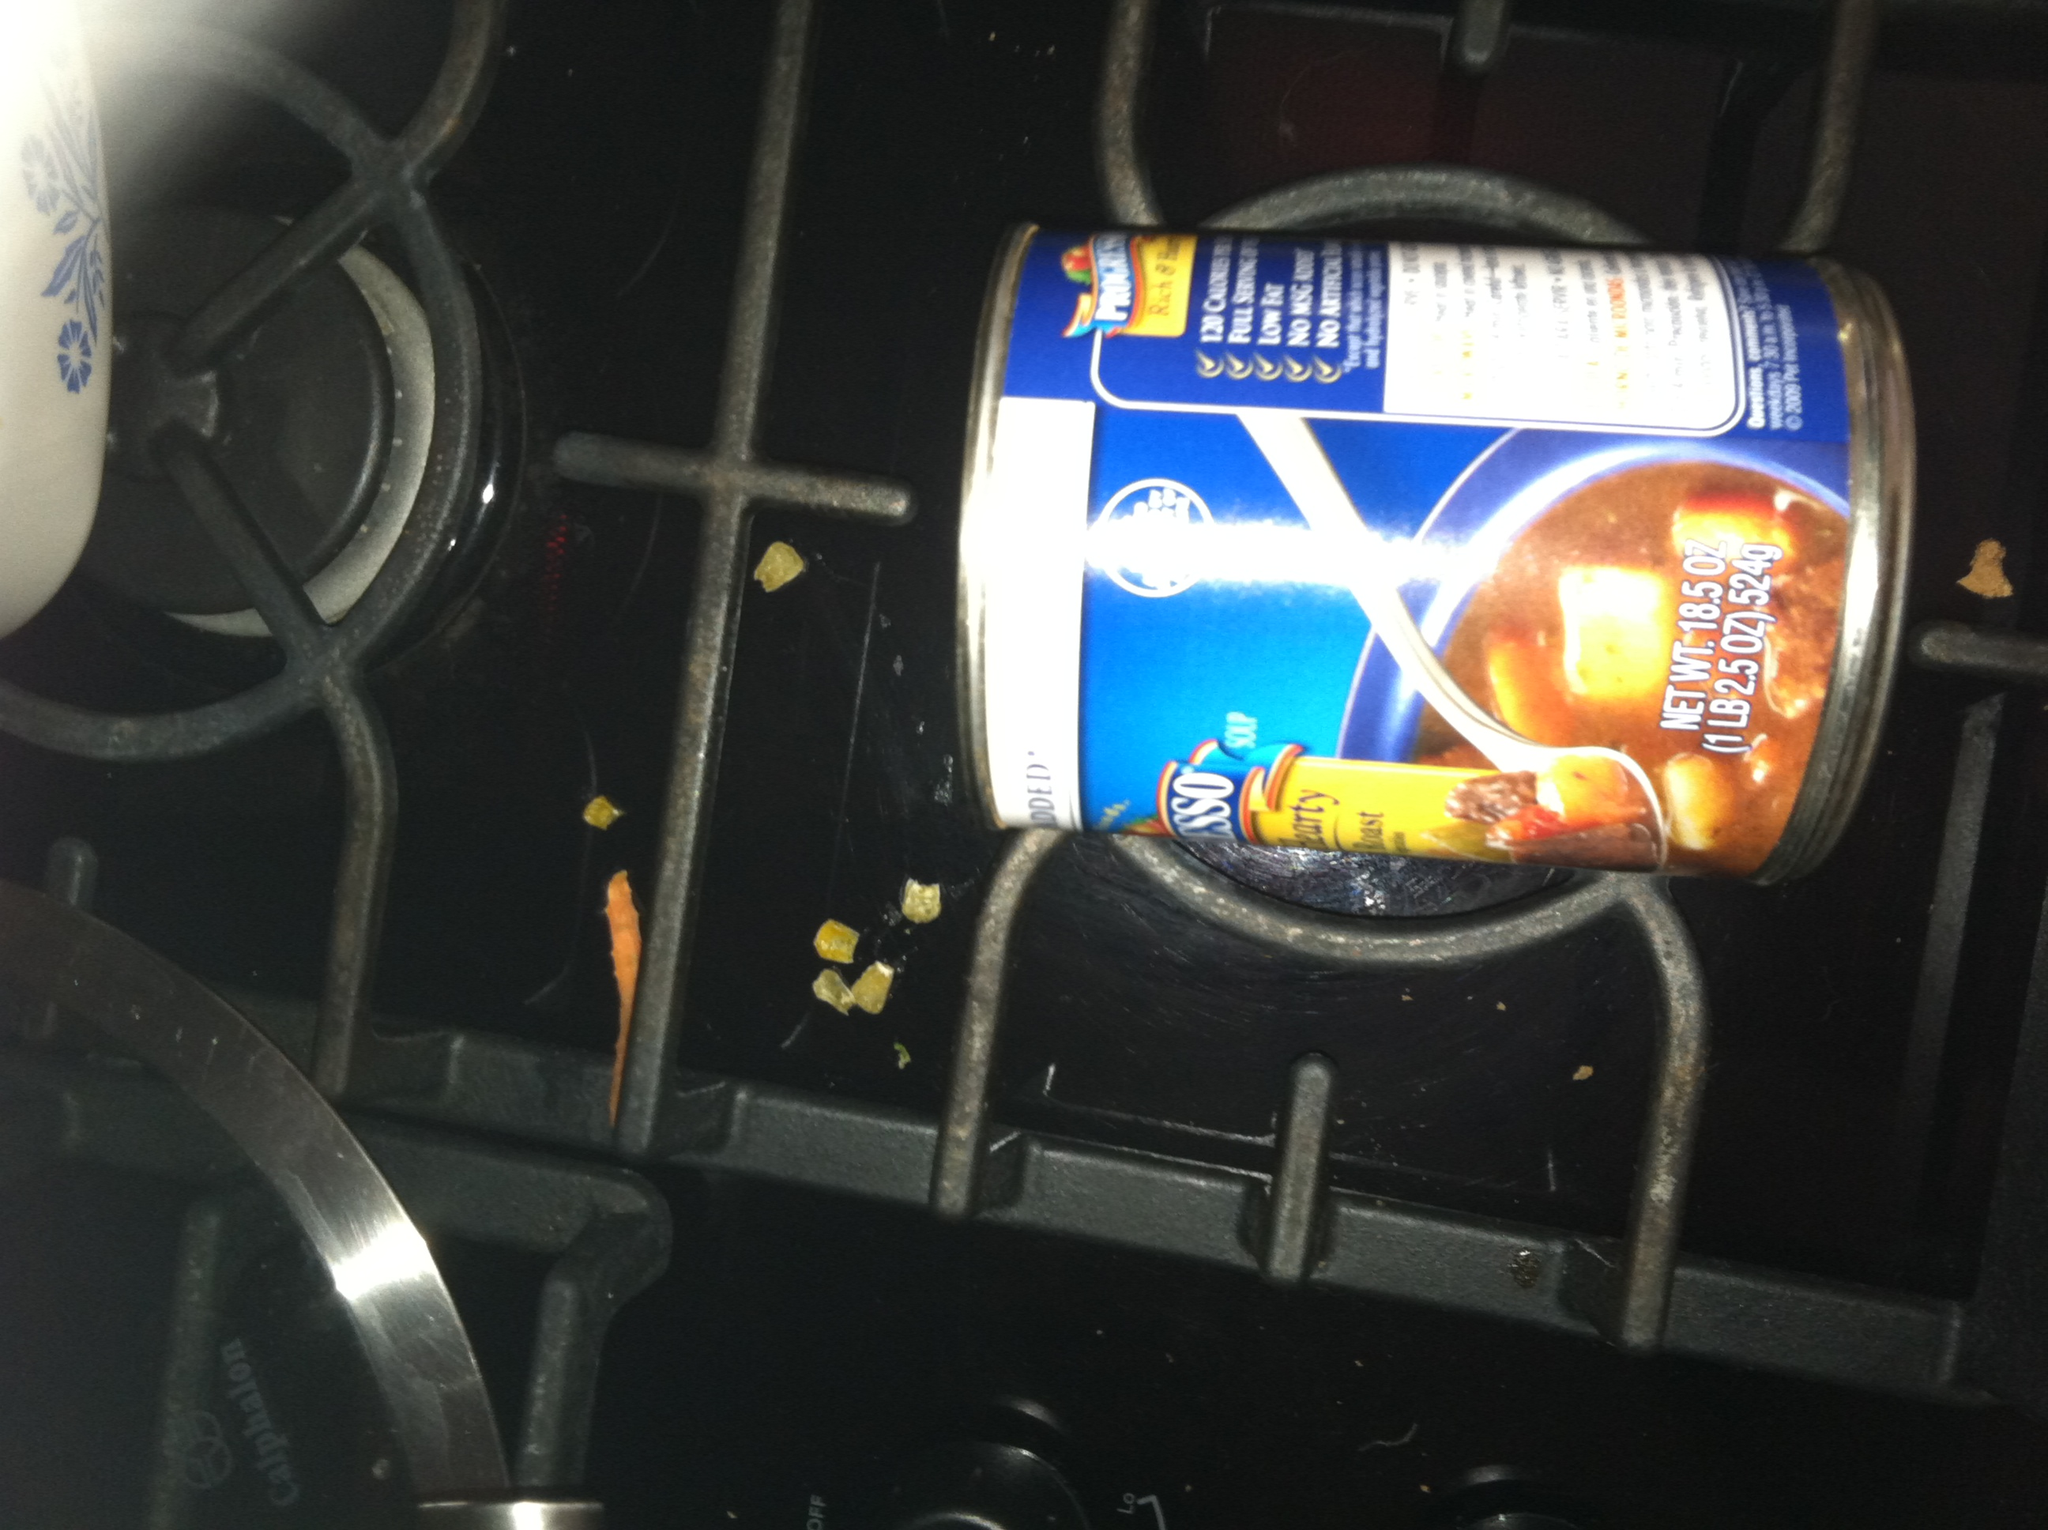Describe what you see in this image. This image shows a can of soup lying on its side on a stove. The can appears to be of Campbell's brand, and there are some small pieces of food debris around the stove's burner. The stove is likely part of a typical kitchen set-up. What kind of dishes can you make with the soup shown in the can? With the can of soup shown in the image, which appears to be a hearty blend of meat and vegetables, you can make a variety of dishes. Simply heating up the soup and serving it with a slice of warm bread makes for a comforting meal. Alternatively, you could use the soup as a base for a more complex dish, such as adding extra vegetables, rice, or pasta to create a more filling stew. For something different, you could use the soup in a casserole, layering it with cooked chicken and cheese for a hearty bake. Create a savory story about an unexpected adventure caused by this can of soup. Once upon a time, in a small kitchen at the edge of a quiet town, sat an unsuspecting can of soup on the stove. Martha, an avid cook, never anticipated that this can would become the focal point of an unforgettable adventure. One chilly evening, as she prepared to open it, a sudden flash of light encapsulated the room, and Martha found herself transported into a sprawling forest, soup can in hand. It turned out that this particular can of soup held ancient magical properties, hidden for centuries. As she navigated the woods, the soup can acted as her compass, leading her to discover hidden groves and ancient ruins. Along the way, she befriended woodland creatures who guided her through enchanted realms, all the while using the hearty contents of the can to gain sustenance and win the trust of mystical beings. By the end of her journey, she uncovered the source of the soup's magic—a crystal spoon buried in the heart of the forest, which, when combined with the can, opened a portal back home. Martha returned, bringing with her not just a crystal spoon but also a heart full of stories and a newfound wonder for the magical possibilities within everyday objects. 